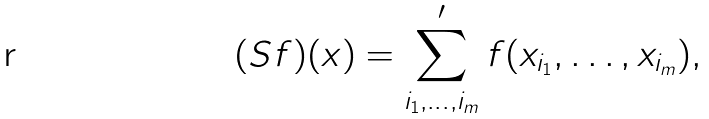<formula> <loc_0><loc_0><loc_500><loc_500>( S f ) ( x ) = \sum _ { i _ { 1 } , \dots , i _ { m } } ^ { \prime } f ( x _ { i _ { 1 } } , \dots , x _ { i _ { m } } ) ,</formula> 